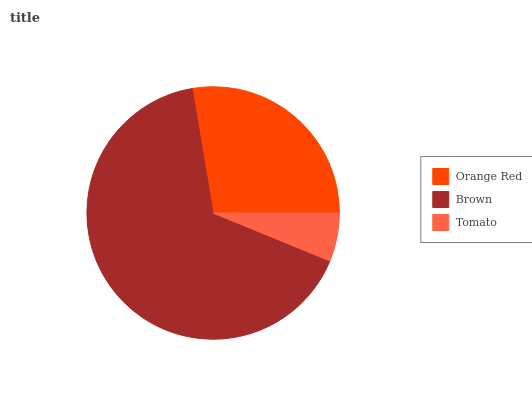Is Tomato the minimum?
Answer yes or no. Yes. Is Brown the maximum?
Answer yes or no. Yes. Is Brown the minimum?
Answer yes or no. No. Is Tomato the maximum?
Answer yes or no. No. Is Brown greater than Tomato?
Answer yes or no. Yes. Is Tomato less than Brown?
Answer yes or no. Yes. Is Tomato greater than Brown?
Answer yes or no. No. Is Brown less than Tomato?
Answer yes or no. No. Is Orange Red the high median?
Answer yes or no. Yes. Is Orange Red the low median?
Answer yes or no. Yes. Is Brown the high median?
Answer yes or no. No. Is Tomato the low median?
Answer yes or no. No. 